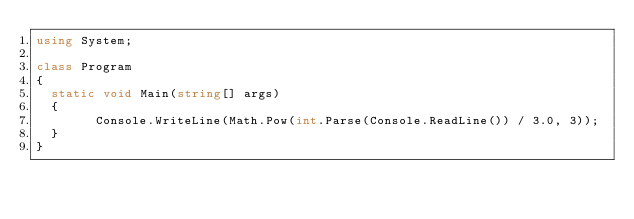<code> <loc_0><loc_0><loc_500><loc_500><_C#_>using System;

class Program
{
	static void Main(string[] args)
	{
        Console.WriteLine(Math.Pow(int.Parse(Console.ReadLine()) / 3.0, 3));
	}
}</code> 